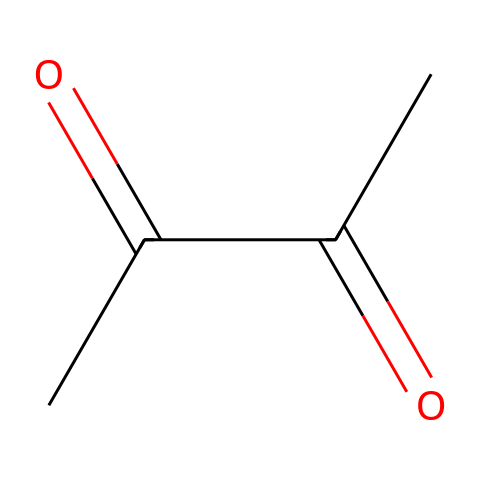What is the molecular formula of this chemical? To find the molecular formula, we need to count the number of each type of atom represented in the SMILES notation. In this case, there are 4 carbon (C) atoms, 6 hydrogen (H) atoms, and 2 oxygen (O) atoms. Therefore, the molecular formula is C4H6O2.
Answer: C4H6O2 How many functional groups are present in the structure? The SMILES representation indicates that there are two carbonyl (C=O) functional groups, which are typical of ketones and aldehydes. Therefore, there are 2 functional groups in the structure.
Answer: 2 Is this compound a polar or non-polar substance? Based on the presence of the carbonyl groups, which are polar due to the difference in electronegativity between carbon and oxygen, the overall molecule exhibits polar characteristics.
Answer: polar What type of intermolecular forces can this compound exhibit? The presence of polar functional groups such as carbonyls allows the molecule to engage in hydrogen bonding and dipole-dipole interactions, which are significant intermolecular forces.
Answer: hydrogen bonding and dipole-dipole interactions What is the principle use of this chemical in food? This compound is commonly used as a flavoring agent in food products, particularly to simulate a buttery taste in popcorn and other snacks.
Answer: flavoring agent How many oxygen atoms are in this molecule? Upon examining the SMILES, we can see that there are 2 oxygen (O) atoms present in the molecular structure of the compound.
Answer: 2 